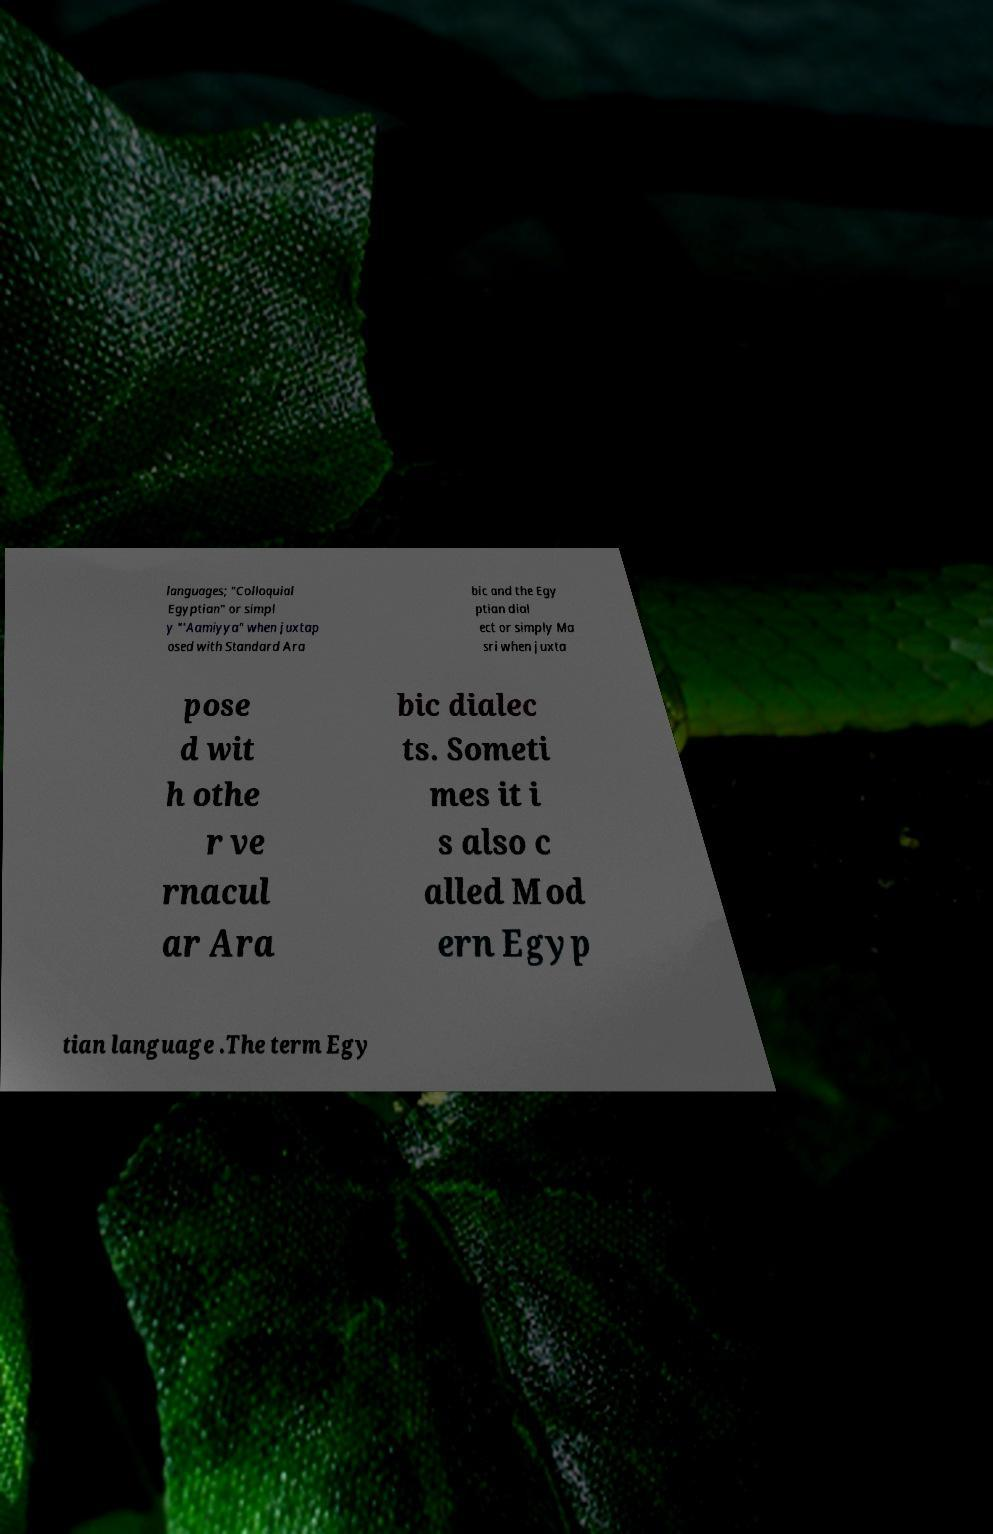I need the written content from this picture converted into text. Can you do that? languages; "Colloquial Egyptian" or simpl y "'Aamiyya" when juxtap osed with Standard Ara bic and the Egy ptian dial ect or simply Ma sri when juxta pose d wit h othe r ve rnacul ar Ara bic dialec ts. Someti mes it i s also c alled Mod ern Egyp tian language .The term Egy 